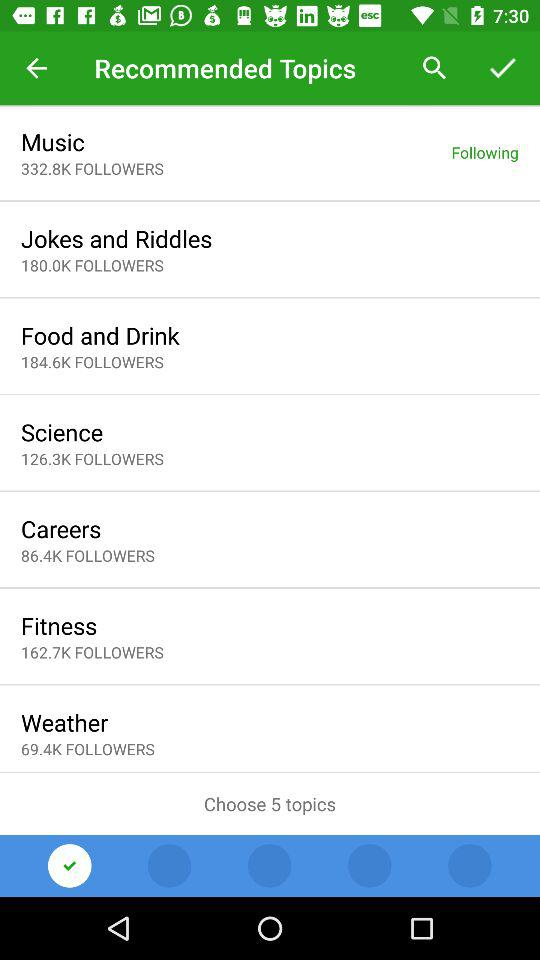How many topics can we choose? You can choose 5 topics. 